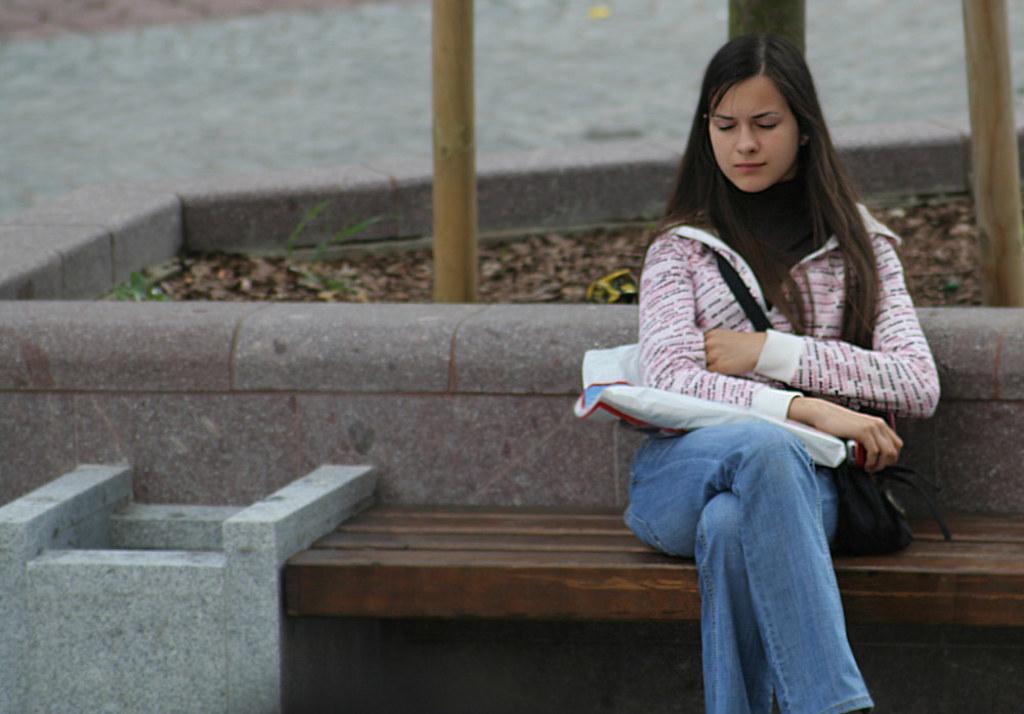Please provide a concise description of this image. In this image we can see a woman is sitting on the wooden surface. She is holding a cover, an object and carrying a bag. Behind her, we can see wooden bamboos and dry leaves. It seems like pavement at the top of the image. We can see a structure in the left bottom of the image. 